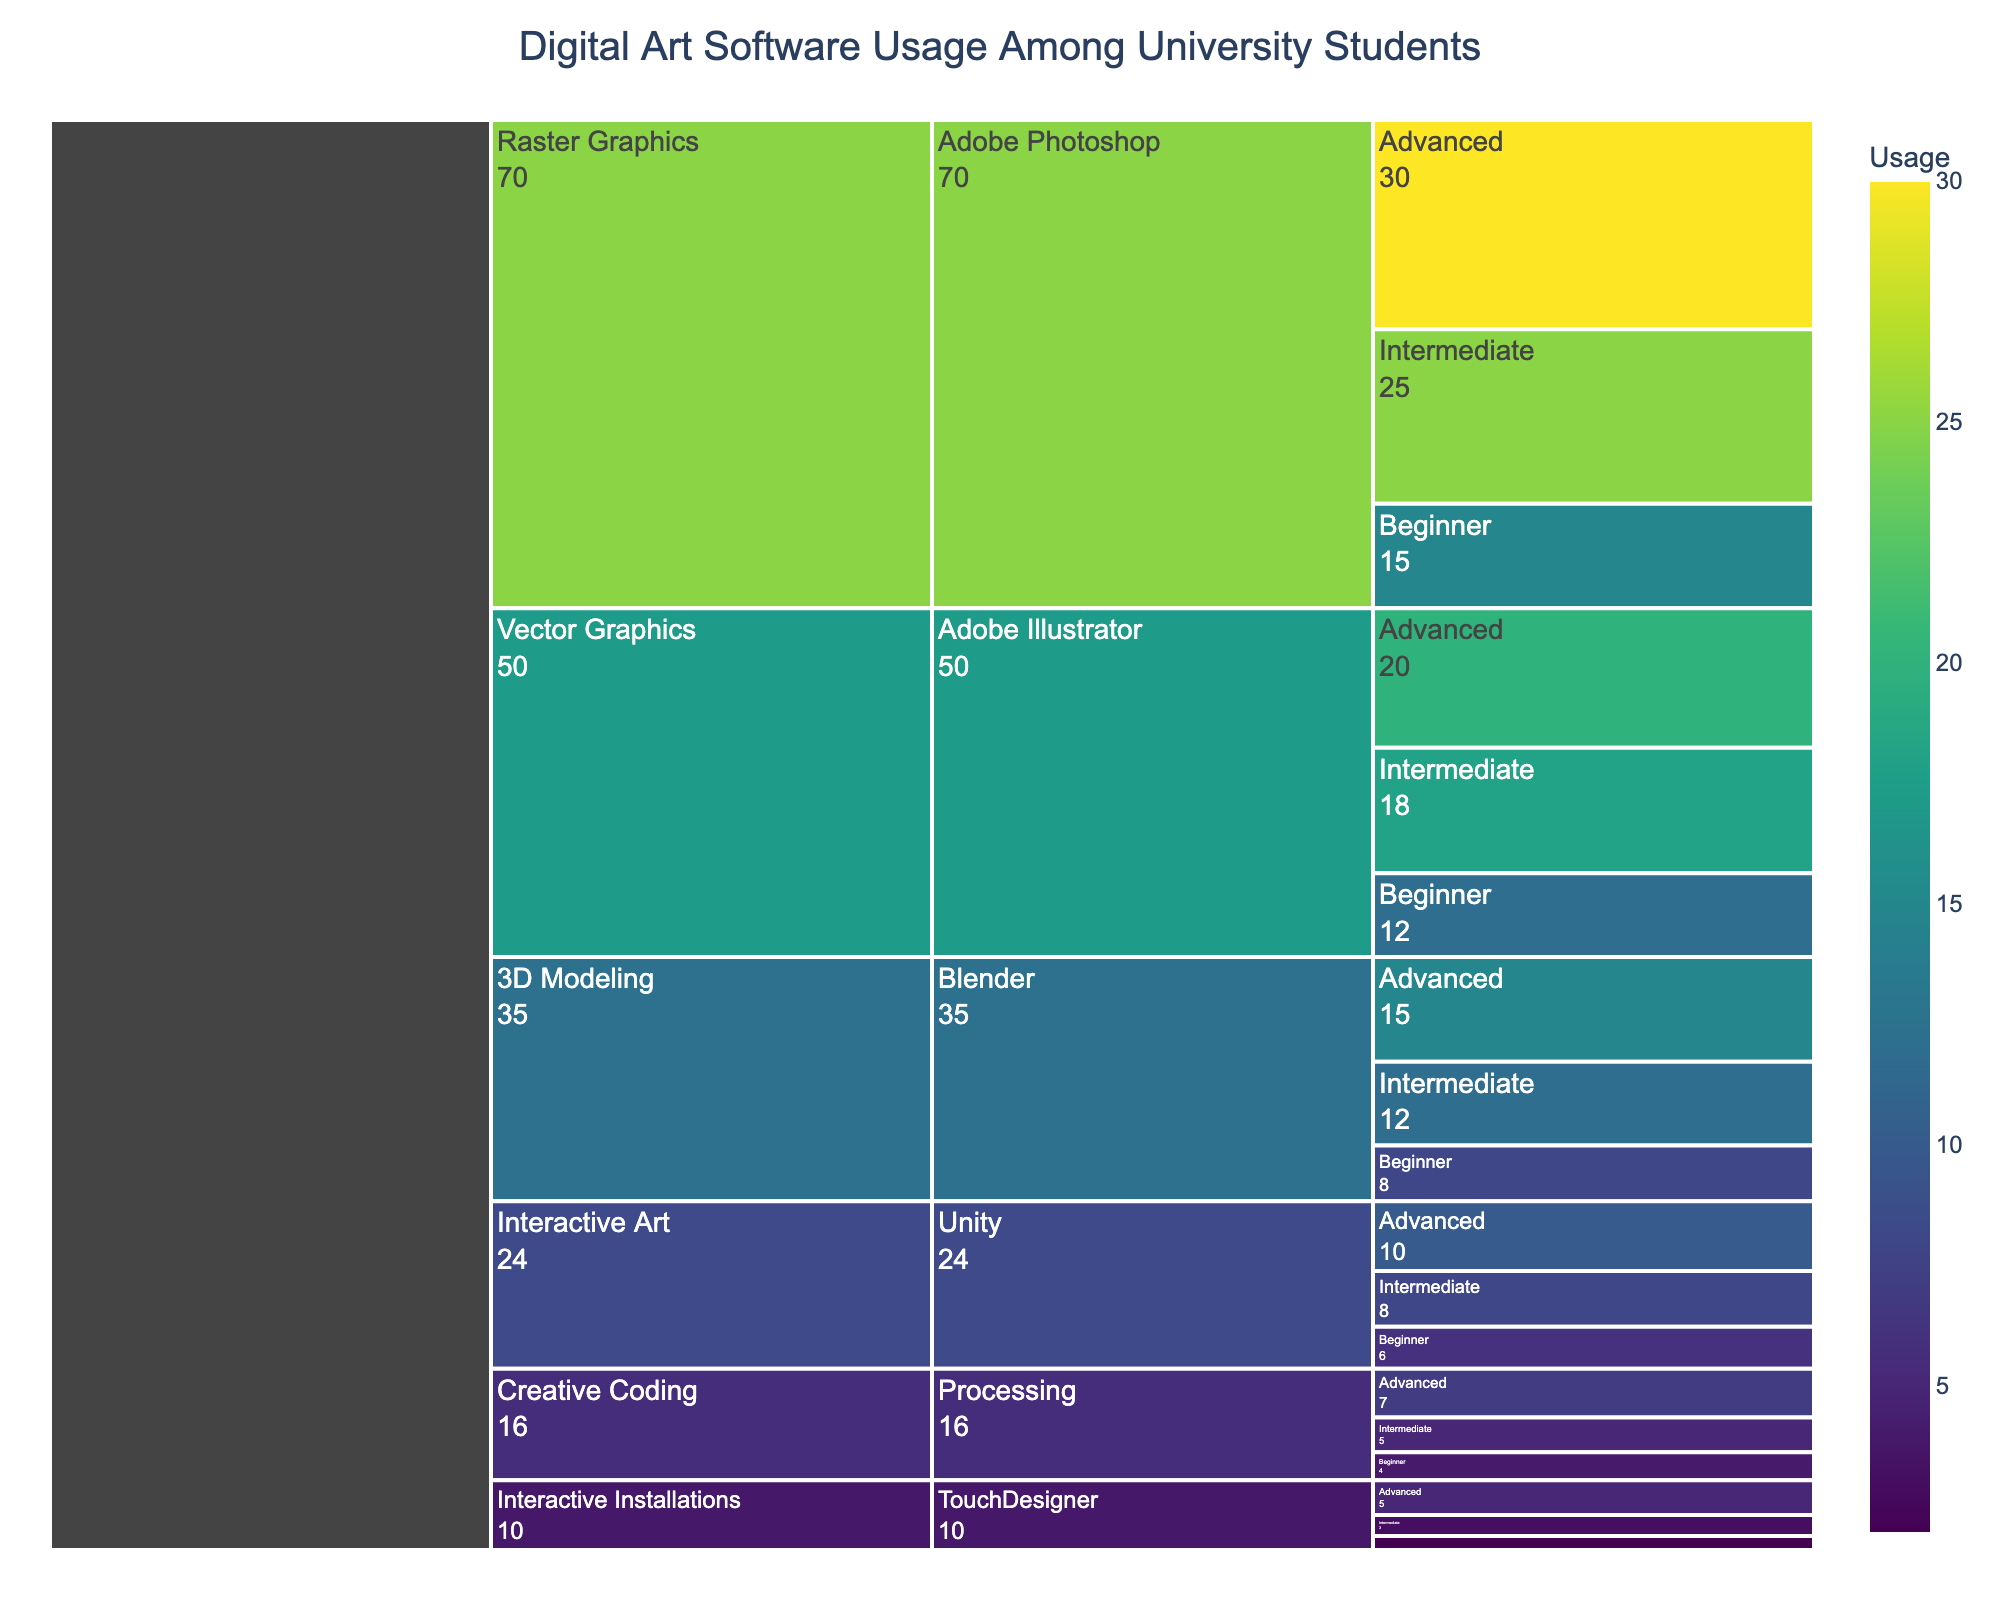Which software has the highest usage among university students? The software with the highest usage is at the top of the Icicle chart under the category with the largest value. Adobe Photoshop under "Raster Graphics" is the top layer with a total of 70 (30 Advanced, 25 Intermediate, and 15 Beginner).
Answer: Adobe Photoshop How does the usage of Blender for intermediate students compare to TouchDesigner for advanced students? From the figure, the usage value for Blender at the intermediate level is 12, and for TouchDesigner at the advanced level, it is 5. Comparing these, Blender has more usage.
Answer: Blender has more usage What is the total usage of software under the "Interactive Art" category? Within the "Interactive Art" category, Unity has 10 (Advanced), 8 (Intermediate), and 6 (Beginner) and TouchDesigner has 5 (Advanced), 3 (Intermediate), and 2 (Beginner). The total is 10+8+6+5+3+2 = 34.
Answer: 34 Which software under "Vector Graphics" has the highest usage by beginner students? Under "Vector Graphics," the beginner level usage is between Adobe Illustrator (12) and there's no other mentioned. So, Adobe Illustrator has the higher value.
Answer: Adobe Illustrator What's the average usage of "3D Modeling" software across all proficiency levels? For "3D Modeling," Blender has 15 (Advanced), 12 (Intermediate), and 8 (Beginner). Sum is 15+12+8 = 35. Average is 35/3 = 11.67.
Answer: 11.67 Is the usage of Processing at the advanced level greater than the usage of TouchDesigner at the intermediate level? Processing at the advanced level has a usage value of 7, and TouchDesigner at the intermediate level has a usage value of 3. Since 7 is greater than 3, the answer is yes.
Answer: Yes What is the total usage for beginners across all software? Summing beginner values: Adobe Photoshop (15), Adobe Illustrator (12), Blender (8), Unity (6), Processing (4), TouchDesigner (2). Total is 15+12+8+6+4+2 = 47.
Answer: 47 Out of all software, which one has the lowest total usage across all proficiency levels? TouchDesigner, with 5 (Advanced), 3 (Intermediate), and 2 (Beginner), sums up to 10, which is the least amount among all software categories.
Answer: TouchDesigner 